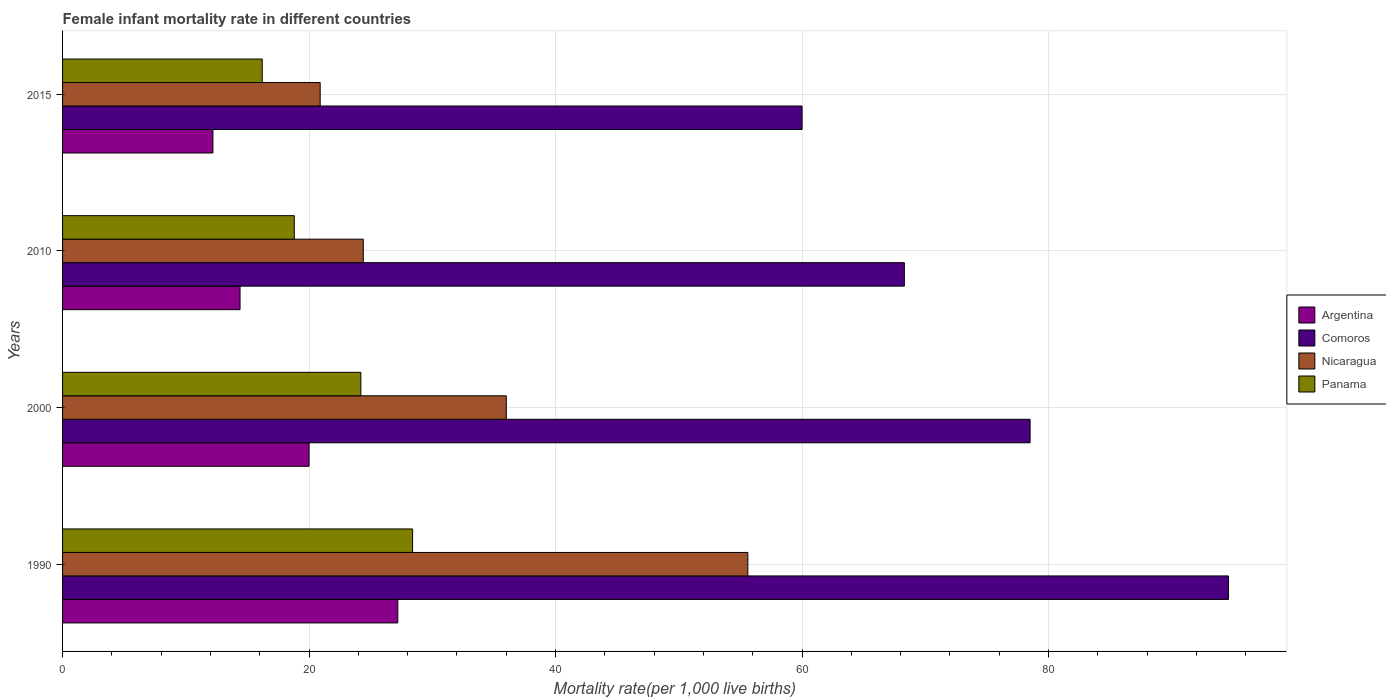How many groups of bars are there?
Ensure brevity in your answer.  4. Are the number of bars on each tick of the Y-axis equal?
Ensure brevity in your answer.  Yes. How many bars are there on the 2nd tick from the bottom?
Your response must be concise. 4. What is the label of the 3rd group of bars from the top?
Ensure brevity in your answer.  2000. In how many cases, is the number of bars for a given year not equal to the number of legend labels?
Provide a short and direct response. 0. What is the female infant mortality rate in Argentina in 2000?
Your response must be concise. 20. Across all years, what is the maximum female infant mortality rate in Panama?
Provide a short and direct response. 28.4. In which year was the female infant mortality rate in Nicaragua minimum?
Your response must be concise. 2015. What is the total female infant mortality rate in Comoros in the graph?
Your answer should be compact. 301.4. What is the difference between the female infant mortality rate in Panama in 2000 and that in 2010?
Keep it short and to the point. 5.4. What is the difference between the female infant mortality rate in Panama in 1990 and the female infant mortality rate in Comoros in 2010?
Keep it short and to the point. -39.9. What is the average female infant mortality rate in Argentina per year?
Offer a terse response. 18.45. In the year 2010, what is the difference between the female infant mortality rate in Comoros and female infant mortality rate in Nicaragua?
Your answer should be compact. 43.9. In how many years, is the female infant mortality rate in Nicaragua greater than 60 ?
Your response must be concise. 0. What is the ratio of the female infant mortality rate in Nicaragua in 1990 to that in 2010?
Your response must be concise. 2.28. Is the female infant mortality rate in Panama in 1990 less than that in 2000?
Your response must be concise. No. What is the difference between the highest and the second highest female infant mortality rate in Nicaragua?
Give a very brief answer. 19.6. Is the sum of the female infant mortality rate in Comoros in 1990 and 2010 greater than the maximum female infant mortality rate in Nicaragua across all years?
Keep it short and to the point. Yes. Is it the case that in every year, the sum of the female infant mortality rate in Argentina and female infant mortality rate in Comoros is greater than the sum of female infant mortality rate in Nicaragua and female infant mortality rate in Panama?
Ensure brevity in your answer.  Yes. What does the 3rd bar from the top in 2015 represents?
Provide a succinct answer. Comoros. What does the 2nd bar from the bottom in 1990 represents?
Keep it short and to the point. Comoros. How many bars are there?
Give a very brief answer. 16. How many years are there in the graph?
Make the answer very short. 4. What is the difference between two consecutive major ticks on the X-axis?
Your answer should be very brief. 20. Are the values on the major ticks of X-axis written in scientific E-notation?
Offer a terse response. No. Does the graph contain any zero values?
Offer a terse response. No. Does the graph contain grids?
Keep it short and to the point. Yes. Where does the legend appear in the graph?
Give a very brief answer. Center right. How are the legend labels stacked?
Your answer should be very brief. Vertical. What is the title of the graph?
Offer a very short reply. Female infant mortality rate in different countries. What is the label or title of the X-axis?
Your answer should be very brief. Mortality rate(per 1,0 live births). What is the Mortality rate(per 1,000 live births) of Argentina in 1990?
Ensure brevity in your answer.  27.2. What is the Mortality rate(per 1,000 live births) of Comoros in 1990?
Your answer should be compact. 94.6. What is the Mortality rate(per 1,000 live births) in Nicaragua in 1990?
Make the answer very short. 55.6. What is the Mortality rate(per 1,000 live births) in Panama in 1990?
Keep it short and to the point. 28.4. What is the Mortality rate(per 1,000 live births) of Argentina in 2000?
Your answer should be compact. 20. What is the Mortality rate(per 1,000 live births) of Comoros in 2000?
Provide a succinct answer. 78.5. What is the Mortality rate(per 1,000 live births) in Panama in 2000?
Make the answer very short. 24.2. What is the Mortality rate(per 1,000 live births) in Comoros in 2010?
Offer a terse response. 68.3. What is the Mortality rate(per 1,000 live births) in Nicaragua in 2010?
Provide a short and direct response. 24.4. What is the Mortality rate(per 1,000 live births) in Panama in 2010?
Make the answer very short. 18.8. What is the Mortality rate(per 1,000 live births) in Nicaragua in 2015?
Provide a succinct answer. 20.9. Across all years, what is the maximum Mortality rate(per 1,000 live births) of Argentina?
Your answer should be very brief. 27.2. Across all years, what is the maximum Mortality rate(per 1,000 live births) in Comoros?
Your answer should be very brief. 94.6. Across all years, what is the maximum Mortality rate(per 1,000 live births) of Nicaragua?
Offer a very short reply. 55.6. Across all years, what is the maximum Mortality rate(per 1,000 live births) of Panama?
Make the answer very short. 28.4. Across all years, what is the minimum Mortality rate(per 1,000 live births) in Comoros?
Keep it short and to the point. 60. Across all years, what is the minimum Mortality rate(per 1,000 live births) of Nicaragua?
Provide a short and direct response. 20.9. Across all years, what is the minimum Mortality rate(per 1,000 live births) in Panama?
Make the answer very short. 16.2. What is the total Mortality rate(per 1,000 live births) of Argentina in the graph?
Your response must be concise. 73.8. What is the total Mortality rate(per 1,000 live births) in Comoros in the graph?
Provide a short and direct response. 301.4. What is the total Mortality rate(per 1,000 live births) in Nicaragua in the graph?
Offer a very short reply. 136.9. What is the total Mortality rate(per 1,000 live births) of Panama in the graph?
Give a very brief answer. 87.6. What is the difference between the Mortality rate(per 1,000 live births) of Argentina in 1990 and that in 2000?
Make the answer very short. 7.2. What is the difference between the Mortality rate(per 1,000 live births) of Nicaragua in 1990 and that in 2000?
Offer a very short reply. 19.6. What is the difference between the Mortality rate(per 1,000 live births) of Panama in 1990 and that in 2000?
Your response must be concise. 4.2. What is the difference between the Mortality rate(per 1,000 live births) of Comoros in 1990 and that in 2010?
Ensure brevity in your answer.  26.3. What is the difference between the Mortality rate(per 1,000 live births) in Nicaragua in 1990 and that in 2010?
Offer a terse response. 31.2. What is the difference between the Mortality rate(per 1,000 live births) of Comoros in 1990 and that in 2015?
Your answer should be compact. 34.6. What is the difference between the Mortality rate(per 1,000 live births) of Nicaragua in 1990 and that in 2015?
Your answer should be compact. 34.7. What is the difference between the Mortality rate(per 1,000 live births) in Panama in 1990 and that in 2015?
Your response must be concise. 12.2. What is the difference between the Mortality rate(per 1,000 live births) of Argentina in 2000 and that in 2010?
Keep it short and to the point. 5.6. What is the difference between the Mortality rate(per 1,000 live births) in Nicaragua in 2000 and that in 2010?
Give a very brief answer. 11.6. What is the difference between the Mortality rate(per 1,000 live births) of Panama in 2000 and that in 2010?
Give a very brief answer. 5.4. What is the difference between the Mortality rate(per 1,000 live births) in Argentina in 2000 and that in 2015?
Your answer should be very brief. 7.8. What is the difference between the Mortality rate(per 1,000 live births) of Panama in 2000 and that in 2015?
Ensure brevity in your answer.  8. What is the difference between the Mortality rate(per 1,000 live births) in Panama in 2010 and that in 2015?
Make the answer very short. 2.6. What is the difference between the Mortality rate(per 1,000 live births) of Argentina in 1990 and the Mortality rate(per 1,000 live births) of Comoros in 2000?
Your answer should be compact. -51.3. What is the difference between the Mortality rate(per 1,000 live births) in Argentina in 1990 and the Mortality rate(per 1,000 live births) in Panama in 2000?
Provide a short and direct response. 3. What is the difference between the Mortality rate(per 1,000 live births) of Comoros in 1990 and the Mortality rate(per 1,000 live births) of Nicaragua in 2000?
Your answer should be compact. 58.6. What is the difference between the Mortality rate(per 1,000 live births) of Comoros in 1990 and the Mortality rate(per 1,000 live births) of Panama in 2000?
Make the answer very short. 70.4. What is the difference between the Mortality rate(per 1,000 live births) in Nicaragua in 1990 and the Mortality rate(per 1,000 live births) in Panama in 2000?
Offer a very short reply. 31.4. What is the difference between the Mortality rate(per 1,000 live births) in Argentina in 1990 and the Mortality rate(per 1,000 live births) in Comoros in 2010?
Offer a very short reply. -41.1. What is the difference between the Mortality rate(per 1,000 live births) in Argentina in 1990 and the Mortality rate(per 1,000 live births) in Nicaragua in 2010?
Give a very brief answer. 2.8. What is the difference between the Mortality rate(per 1,000 live births) in Comoros in 1990 and the Mortality rate(per 1,000 live births) in Nicaragua in 2010?
Ensure brevity in your answer.  70.2. What is the difference between the Mortality rate(per 1,000 live births) in Comoros in 1990 and the Mortality rate(per 1,000 live births) in Panama in 2010?
Your response must be concise. 75.8. What is the difference between the Mortality rate(per 1,000 live births) in Nicaragua in 1990 and the Mortality rate(per 1,000 live births) in Panama in 2010?
Offer a terse response. 36.8. What is the difference between the Mortality rate(per 1,000 live births) in Argentina in 1990 and the Mortality rate(per 1,000 live births) in Comoros in 2015?
Your answer should be very brief. -32.8. What is the difference between the Mortality rate(per 1,000 live births) in Comoros in 1990 and the Mortality rate(per 1,000 live births) in Nicaragua in 2015?
Your answer should be very brief. 73.7. What is the difference between the Mortality rate(per 1,000 live births) in Comoros in 1990 and the Mortality rate(per 1,000 live births) in Panama in 2015?
Provide a short and direct response. 78.4. What is the difference between the Mortality rate(per 1,000 live births) in Nicaragua in 1990 and the Mortality rate(per 1,000 live births) in Panama in 2015?
Offer a terse response. 39.4. What is the difference between the Mortality rate(per 1,000 live births) in Argentina in 2000 and the Mortality rate(per 1,000 live births) in Comoros in 2010?
Offer a terse response. -48.3. What is the difference between the Mortality rate(per 1,000 live births) of Argentina in 2000 and the Mortality rate(per 1,000 live births) of Panama in 2010?
Keep it short and to the point. 1.2. What is the difference between the Mortality rate(per 1,000 live births) of Comoros in 2000 and the Mortality rate(per 1,000 live births) of Nicaragua in 2010?
Provide a succinct answer. 54.1. What is the difference between the Mortality rate(per 1,000 live births) of Comoros in 2000 and the Mortality rate(per 1,000 live births) of Panama in 2010?
Give a very brief answer. 59.7. What is the difference between the Mortality rate(per 1,000 live births) in Argentina in 2000 and the Mortality rate(per 1,000 live births) in Nicaragua in 2015?
Your answer should be compact. -0.9. What is the difference between the Mortality rate(per 1,000 live births) of Comoros in 2000 and the Mortality rate(per 1,000 live births) of Nicaragua in 2015?
Provide a short and direct response. 57.6. What is the difference between the Mortality rate(per 1,000 live births) in Comoros in 2000 and the Mortality rate(per 1,000 live births) in Panama in 2015?
Your answer should be compact. 62.3. What is the difference between the Mortality rate(per 1,000 live births) in Nicaragua in 2000 and the Mortality rate(per 1,000 live births) in Panama in 2015?
Your response must be concise. 19.8. What is the difference between the Mortality rate(per 1,000 live births) in Argentina in 2010 and the Mortality rate(per 1,000 live births) in Comoros in 2015?
Your answer should be very brief. -45.6. What is the difference between the Mortality rate(per 1,000 live births) of Argentina in 2010 and the Mortality rate(per 1,000 live births) of Panama in 2015?
Ensure brevity in your answer.  -1.8. What is the difference between the Mortality rate(per 1,000 live births) of Comoros in 2010 and the Mortality rate(per 1,000 live births) of Nicaragua in 2015?
Provide a short and direct response. 47.4. What is the difference between the Mortality rate(per 1,000 live births) of Comoros in 2010 and the Mortality rate(per 1,000 live births) of Panama in 2015?
Make the answer very short. 52.1. What is the difference between the Mortality rate(per 1,000 live births) in Nicaragua in 2010 and the Mortality rate(per 1,000 live births) in Panama in 2015?
Make the answer very short. 8.2. What is the average Mortality rate(per 1,000 live births) in Argentina per year?
Make the answer very short. 18.45. What is the average Mortality rate(per 1,000 live births) in Comoros per year?
Your response must be concise. 75.35. What is the average Mortality rate(per 1,000 live births) in Nicaragua per year?
Your response must be concise. 34.23. What is the average Mortality rate(per 1,000 live births) of Panama per year?
Make the answer very short. 21.9. In the year 1990, what is the difference between the Mortality rate(per 1,000 live births) in Argentina and Mortality rate(per 1,000 live births) in Comoros?
Keep it short and to the point. -67.4. In the year 1990, what is the difference between the Mortality rate(per 1,000 live births) of Argentina and Mortality rate(per 1,000 live births) of Nicaragua?
Your answer should be compact. -28.4. In the year 1990, what is the difference between the Mortality rate(per 1,000 live births) in Comoros and Mortality rate(per 1,000 live births) in Nicaragua?
Provide a succinct answer. 39. In the year 1990, what is the difference between the Mortality rate(per 1,000 live births) in Comoros and Mortality rate(per 1,000 live births) in Panama?
Give a very brief answer. 66.2. In the year 1990, what is the difference between the Mortality rate(per 1,000 live births) in Nicaragua and Mortality rate(per 1,000 live births) in Panama?
Provide a succinct answer. 27.2. In the year 2000, what is the difference between the Mortality rate(per 1,000 live births) of Argentina and Mortality rate(per 1,000 live births) of Comoros?
Make the answer very short. -58.5. In the year 2000, what is the difference between the Mortality rate(per 1,000 live births) in Argentina and Mortality rate(per 1,000 live births) in Nicaragua?
Offer a very short reply. -16. In the year 2000, what is the difference between the Mortality rate(per 1,000 live births) of Argentina and Mortality rate(per 1,000 live births) of Panama?
Your answer should be very brief. -4.2. In the year 2000, what is the difference between the Mortality rate(per 1,000 live births) of Comoros and Mortality rate(per 1,000 live births) of Nicaragua?
Your answer should be compact. 42.5. In the year 2000, what is the difference between the Mortality rate(per 1,000 live births) of Comoros and Mortality rate(per 1,000 live births) of Panama?
Ensure brevity in your answer.  54.3. In the year 2010, what is the difference between the Mortality rate(per 1,000 live births) in Argentina and Mortality rate(per 1,000 live births) in Comoros?
Your response must be concise. -53.9. In the year 2010, what is the difference between the Mortality rate(per 1,000 live births) of Argentina and Mortality rate(per 1,000 live births) of Panama?
Offer a very short reply. -4.4. In the year 2010, what is the difference between the Mortality rate(per 1,000 live births) of Comoros and Mortality rate(per 1,000 live births) of Nicaragua?
Offer a very short reply. 43.9. In the year 2010, what is the difference between the Mortality rate(per 1,000 live births) in Comoros and Mortality rate(per 1,000 live births) in Panama?
Give a very brief answer. 49.5. In the year 2015, what is the difference between the Mortality rate(per 1,000 live births) in Argentina and Mortality rate(per 1,000 live births) in Comoros?
Give a very brief answer. -47.8. In the year 2015, what is the difference between the Mortality rate(per 1,000 live births) in Argentina and Mortality rate(per 1,000 live births) in Nicaragua?
Ensure brevity in your answer.  -8.7. In the year 2015, what is the difference between the Mortality rate(per 1,000 live births) of Comoros and Mortality rate(per 1,000 live births) of Nicaragua?
Give a very brief answer. 39.1. In the year 2015, what is the difference between the Mortality rate(per 1,000 live births) in Comoros and Mortality rate(per 1,000 live births) in Panama?
Your answer should be very brief. 43.8. What is the ratio of the Mortality rate(per 1,000 live births) in Argentina in 1990 to that in 2000?
Your answer should be very brief. 1.36. What is the ratio of the Mortality rate(per 1,000 live births) of Comoros in 1990 to that in 2000?
Your answer should be compact. 1.21. What is the ratio of the Mortality rate(per 1,000 live births) of Nicaragua in 1990 to that in 2000?
Offer a very short reply. 1.54. What is the ratio of the Mortality rate(per 1,000 live births) in Panama in 1990 to that in 2000?
Your answer should be compact. 1.17. What is the ratio of the Mortality rate(per 1,000 live births) in Argentina in 1990 to that in 2010?
Offer a terse response. 1.89. What is the ratio of the Mortality rate(per 1,000 live births) of Comoros in 1990 to that in 2010?
Your answer should be compact. 1.39. What is the ratio of the Mortality rate(per 1,000 live births) in Nicaragua in 1990 to that in 2010?
Provide a short and direct response. 2.28. What is the ratio of the Mortality rate(per 1,000 live births) of Panama in 1990 to that in 2010?
Provide a succinct answer. 1.51. What is the ratio of the Mortality rate(per 1,000 live births) in Argentina in 1990 to that in 2015?
Provide a short and direct response. 2.23. What is the ratio of the Mortality rate(per 1,000 live births) in Comoros in 1990 to that in 2015?
Ensure brevity in your answer.  1.58. What is the ratio of the Mortality rate(per 1,000 live births) in Nicaragua in 1990 to that in 2015?
Keep it short and to the point. 2.66. What is the ratio of the Mortality rate(per 1,000 live births) of Panama in 1990 to that in 2015?
Offer a very short reply. 1.75. What is the ratio of the Mortality rate(per 1,000 live births) of Argentina in 2000 to that in 2010?
Offer a very short reply. 1.39. What is the ratio of the Mortality rate(per 1,000 live births) of Comoros in 2000 to that in 2010?
Provide a succinct answer. 1.15. What is the ratio of the Mortality rate(per 1,000 live births) in Nicaragua in 2000 to that in 2010?
Ensure brevity in your answer.  1.48. What is the ratio of the Mortality rate(per 1,000 live births) of Panama in 2000 to that in 2010?
Provide a succinct answer. 1.29. What is the ratio of the Mortality rate(per 1,000 live births) of Argentina in 2000 to that in 2015?
Offer a terse response. 1.64. What is the ratio of the Mortality rate(per 1,000 live births) in Comoros in 2000 to that in 2015?
Offer a very short reply. 1.31. What is the ratio of the Mortality rate(per 1,000 live births) of Nicaragua in 2000 to that in 2015?
Your answer should be compact. 1.72. What is the ratio of the Mortality rate(per 1,000 live births) in Panama in 2000 to that in 2015?
Keep it short and to the point. 1.49. What is the ratio of the Mortality rate(per 1,000 live births) in Argentina in 2010 to that in 2015?
Your answer should be very brief. 1.18. What is the ratio of the Mortality rate(per 1,000 live births) of Comoros in 2010 to that in 2015?
Give a very brief answer. 1.14. What is the ratio of the Mortality rate(per 1,000 live births) of Nicaragua in 2010 to that in 2015?
Provide a short and direct response. 1.17. What is the ratio of the Mortality rate(per 1,000 live births) in Panama in 2010 to that in 2015?
Make the answer very short. 1.16. What is the difference between the highest and the second highest Mortality rate(per 1,000 live births) of Argentina?
Offer a very short reply. 7.2. What is the difference between the highest and the second highest Mortality rate(per 1,000 live births) in Comoros?
Your answer should be very brief. 16.1. What is the difference between the highest and the second highest Mortality rate(per 1,000 live births) of Nicaragua?
Your answer should be very brief. 19.6. What is the difference between the highest and the second highest Mortality rate(per 1,000 live births) in Panama?
Offer a terse response. 4.2. What is the difference between the highest and the lowest Mortality rate(per 1,000 live births) in Argentina?
Your answer should be compact. 15. What is the difference between the highest and the lowest Mortality rate(per 1,000 live births) in Comoros?
Keep it short and to the point. 34.6. What is the difference between the highest and the lowest Mortality rate(per 1,000 live births) in Nicaragua?
Offer a terse response. 34.7. What is the difference between the highest and the lowest Mortality rate(per 1,000 live births) of Panama?
Your answer should be compact. 12.2. 